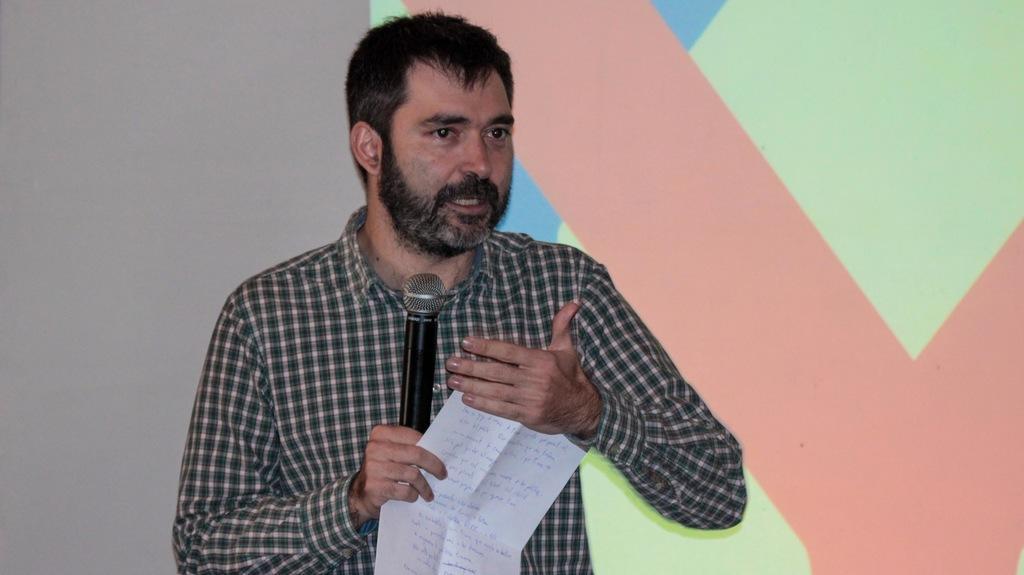Can you describe this image briefly? In this image i can see a man is standing and holding a microphone and a piece of paper in his hand. He is wearing a shirt. 